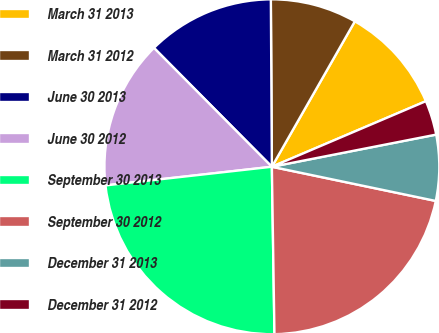<chart> <loc_0><loc_0><loc_500><loc_500><pie_chart><fcel>March 31 2013<fcel>March 31 2012<fcel>June 30 2013<fcel>June 30 2012<fcel>September 30 2013<fcel>September 30 2012<fcel>December 31 2013<fcel>December 31 2012<nl><fcel>10.34%<fcel>8.35%<fcel>12.34%<fcel>14.34%<fcel>23.47%<fcel>21.48%<fcel>6.35%<fcel>3.33%<nl></chart> 